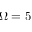<formula> <loc_0><loc_0><loc_500><loc_500>\Omega = 5</formula> 